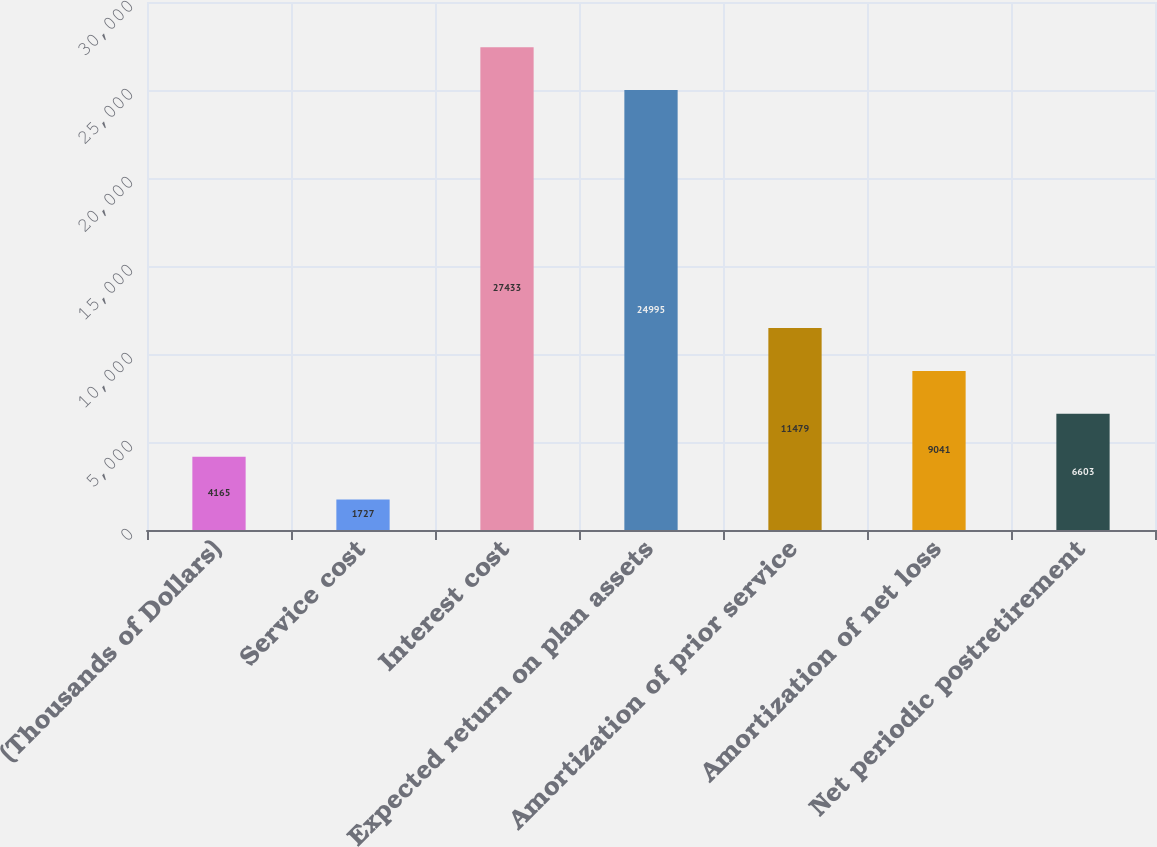Convert chart. <chart><loc_0><loc_0><loc_500><loc_500><bar_chart><fcel>(Thousands of Dollars)<fcel>Service cost<fcel>Interest cost<fcel>Expected return on plan assets<fcel>Amortization of prior service<fcel>Amortization of net loss<fcel>Net periodic postretirement<nl><fcel>4165<fcel>1727<fcel>27433<fcel>24995<fcel>11479<fcel>9041<fcel>6603<nl></chart> 